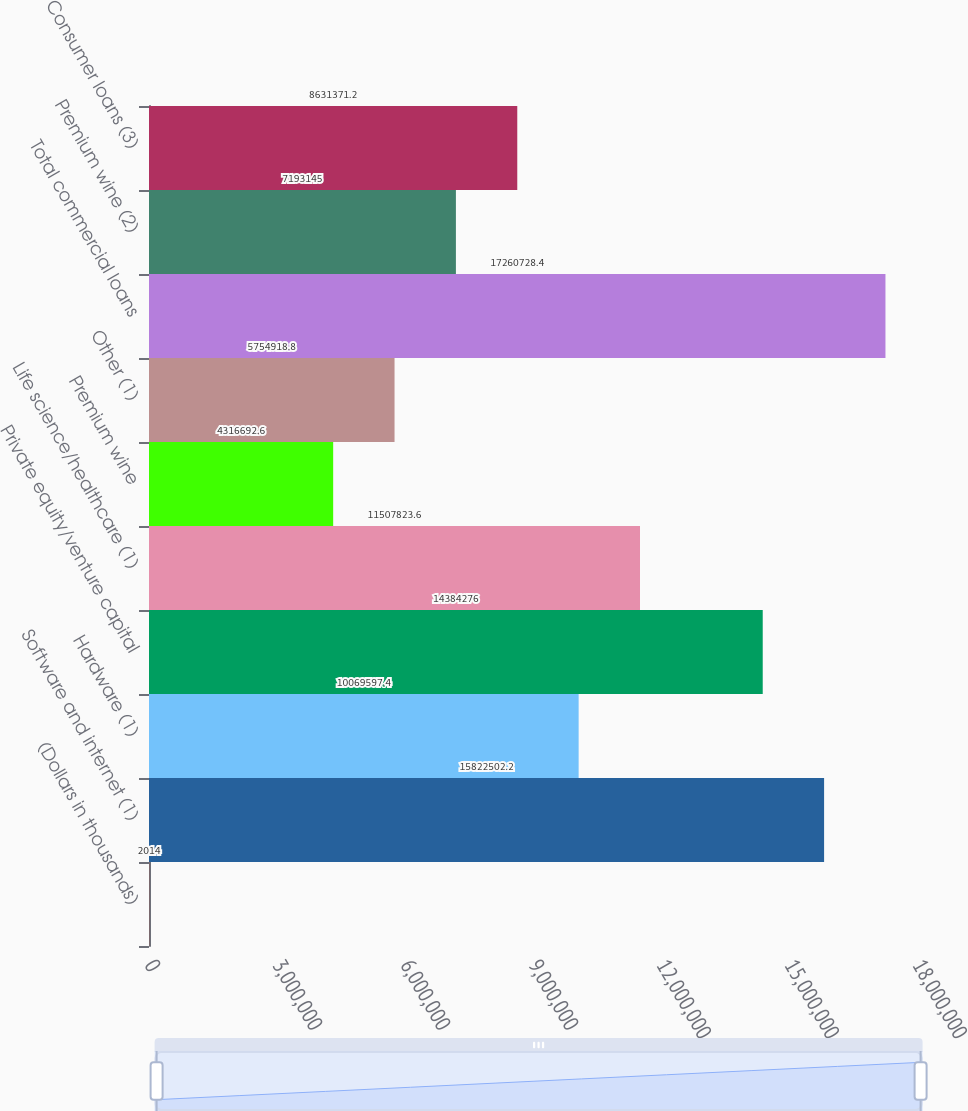Convert chart. <chart><loc_0><loc_0><loc_500><loc_500><bar_chart><fcel>(Dollars in thousands)<fcel>Software and internet (1)<fcel>Hardware (1)<fcel>Private equity/venture capital<fcel>Life science/healthcare (1)<fcel>Premium wine<fcel>Other (1)<fcel>Total commercial loans<fcel>Premium wine (2)<fcel>Consumer loans (3)<nl><fcel>2014<fcel>1.58225e+07<fcel>1.00696e+07<fcel>1.43843e+07<fcel>1.15078e+07<fcel>4.31669e+06<fcel>5.75492e+06<fcel>1.72607e+07<fcel>7.19314e+06<fcel>8.63137e+06<nl></chart> 